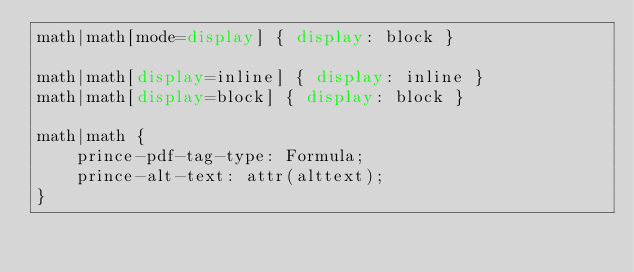Convert code to text. <code><loc_0><loc_0><loc_500><loc_500><_CSS_>math|math[mode=display] { display: block }

math|math[display=inline] { display: inline }
math|math[display=block] { display: block }

math|math {
    prince-pdf-tag-type: Formula;
    prince-alt-text: attr(alttext);
}

</code> 